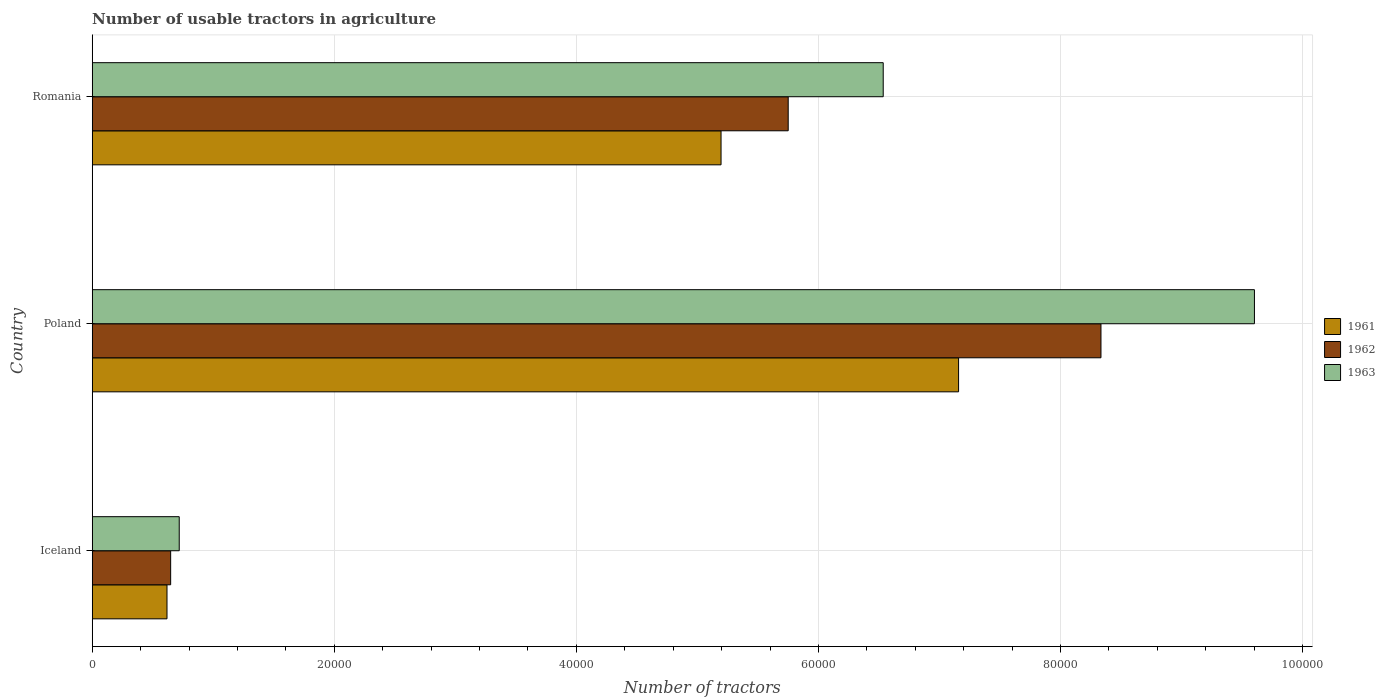How many different coloured bars are there?
Your answer should be compact. 3. Are the number of bars per tick equal to the number of legend labels?
Give a very brief answer. Yes. How many bars are there on the 2nd tick from the top?
Keep it short and to the point. 3. In how many cases, is the number of bars for a given country not equal to the number of legend labels?
Ensure brevity in your answer.  0. What is the number of usable tractors in agriculture in 1961 in Poland?
Your response must be concise. 7.16e+04. Across all countries, what is the maximum number of usable tractors in agriculture in 1963?
Provide a short and direct response. 9.60e+04. Across all countries, what is the minimum number of usable tractors in agriculture in 1962?
Offer a very short reply. 6479. In which country was the number of usable tractors in agriculture in 1963 maximum?
Provide a short and direct response. Poland. In which country was the number of usable tractors in agriculture in 1962 minimum?
Offer a terse response. Iceland. What is the total number of usable tractors in agriculture in 1962 in the graph?
Keep it short and to the point. 1.47e+05. What is the difference between the number of usable tractors in agriculture in 1963 in Iceland and that in Romania?
Make the answer very short. -5.82e+04. What is the difference between the number of usable tractors in agriculture in 1963 in Romania and the number of usable tractors in agriculture in 1962 in Iceland?
Provide a succinct answer. 5.89e+04. What is the average number of usable tractors in agriculture in 1961 per country?
Your answer should be compact. 4.32e+04. What is the difference between the number of usable tractors in agriculture in 1963 and number of usable tractors in agriculture in 1962 in Poland?
Give a very brief answer. 1.27e+04. In how many countries, is the number of usable tractors in agriculture in 1961 greater than 24000 ?
Your response must be concise. 2. What is the ratio of the number of usable tractors in agriculture in 1962 in Iceland to that in Poland?
Your answer should be compact. 0.08. Is the number of usable tractors in agriculture in 1963 in Iceland less than that in Poland?
Give a very brief answer. Yes. Is the difference between the number of usable tractors in agriculture in 1963 in Iceland and Romania greater than the difference between the number of usable tractors in agriculture in 1962 in Iceland and Romania?
Keep it short and to the point. No. What is the difference between the highest and the second highest number of usable tractors in agriculture in 1963?
Provide a short and direct response. 3.07e+04. What is the difference between the highest and the lowest number of usable tractors in agriculture in 1963?
Your answer should be compact. 8.88e+04. In how many countries, is the number of usable tractors in agriculture in 1962 greater than the average number of usable tractors in agriculture in 1962 taken over all countries?
Your response must be concise. 2. What does the 2nd bar from the top in Poland represents?
Make the answer very short. 1962. What does the 3rd bar from the bottom in Romania represents?
Offer a terse response. 1963. Is it the case that in every country, the sum of the number of usable tractors in agriculture in 1962 and number of usable tractors in agriculture in 1961 is greater than the number of usable tractors in agriculture in 1963?
Make the answer very short. Yes. How many bars are there?
Your response must be concise. 9. Are all the bars in the graph horizontal?
Keep it short and to the point. Yes. What is the difference between two consecutive major ticks on the X-axis?
Your answer should be very brief. 2.00e+04. Are the values on the major ticks of X-axis written in scientific E-notation?
Offer a very short reply. No. Does the graph contain any zero values?
Your answer should be compact. No. Where does the legend appear in the graph?
Your answer should be compact. Center right. What is the title of the graph?
Ensure brevity in your answer.  Number of usable tractors in agriculture. What is the label or title of the X-axis?
Ensure brevity in your answer.  Number of tractors. What is the Number of tractors of 1961 in Iceland?
Offer a terse response. 6177. What is the Number of tractors of 1962 in Iceland?
Provide a succinct answer. 6479. What is the Number of tractors in 1963 in Iceland?
Keep it short and to the point. 7187. What is the Number of tractors in 1961 in Poland?
Ensure brevity in your answer.  7.16e+04. What is the Number of tractors of 1962 in Poland?
Your response must be concise. 8.33e+04. What is the Number of tractors of 1963 in Poland?
Provide a succinct answer. 9.60e+04. What is the Number of tractors of 1961 in Romania?
Offer a terse response. 5.20e+04. What is the Number of tractors of 1962 in Romania?
Your response must be concise. 5.75e+04. What is the Number of tractors of 1963 in Romania?
Ensure brevity in your answer.  6.54e+04. Across all countries, what is the maximum Number of tractors in 1961?
Keep it short and to the point. 7.16e+04. Across all countries, what is the maximum Number of tractors of 1962?
Keep it short and to the point. 8.33e+04. Across all countries, what is the maximum Number of tractors of 1963?
Your answer should be very brief. 9.60e+04. Across all countries, what is the minimum Number of tractors of 1961?
Your answer should be compact. 6177. Across all countries, what is the minimum Number of tractors of 1962?
Give a very brief answer. 6479. Across all countries, what is the minimum Number of tractors of 1963?
Offer a terse response. 7187. What is the total Number of tractors in 1961 in the graph?
Keep it short and to the point. 1.30e+05. What is the total Number of tractors in 1962 in the graph?
Your answer should be very brief. 1.47e+05. What is the total Number of tractors of 1963 in the graph?
Your answer should be very brief. 1.69e+05. What is the difference between the Number of tractors in 1961 in Iceland and that in Poland?
Offer a terse response. -6.54e+04. What is the difference between the Number of tractors in 1962 in Iceland and that in Poland?
Ensure brevity in your answer.  -7.69e+04. What is the difference between the Number of tractors of 1963 in Iceland and that in Poland?
Make the answer very short. -8.88e+04. What is the difference between the Number of tractors in 1961 in Iceland and that in Romania?
Provide a succinct answer. -4.58e+04. What is the difference between the Number of tractors of 1962 in Iceland and that in Romania?
Offer a very short reply. -5.10e+04. What is the difference between the Number of tractors of 1963 in Iceland and that in Romania?
Ensure brevity in your answer.  -5.82e+04. What is the difference between the Number of tractors of 1961 in Poland and that in Romania?
Provide a succinct answer. 1.96e+04. What is the difference between the Number of tractors of 1962 in Poland and that in Romania?
Make the answer very short. 2.58e+04. What is the difference between the Number of tractors in 1963 in Poland and that in Romania?
Your response must be concise. 3.07e+04. What is the difference between the Number of tractors in 1961 in Iceland and the Number of tractors in 1962 in Poland?
Provide a short and direct response. -7.72e+04. What is the difference between the Number of tractors in 1961 in Iceland and the Number of tractors in 1963 in Poland?
Ensure brevity in your answer.  -8.98e+04. What is the difference between the Number of tractors of 1962 in Iceland and the Number of tractors of 1963 in Poland?
Give a very brief answer. -8.95e+04. What is the difference between the Number of tractors of 1961 in Iceland and the Number of tractors of 1962 in Romania?
Offer a very short reply. -5.13e+04. What is the difference between the Number of tractors of 1961 in Iceland and the Number of tractors of 1963 in Romania?
Make the answer very short. -5.92e+04. What is the difference between the Number of tractors of 1962 in Iceland and the Number of tractors of 1963 in Romania?
Your response must be concise. -5.89e+04. What is the difference between the Number of tractors of 1961 in Poland and the Number of tractors of 1962 in Romania?
Offer a terse response. 1.41e+04. What is the difference between the Number of tractors in 1961 in Poland and the Number of tractors in 1963 in Romania?
Make the answer very short. 6226. What is the difference between the Number of tractors in 1962 in Poland and the Number of tractors in 1963 in Romania?
Your answer should be very brief. 1.80e+04. What is the average Number of tractors in 1961 per country?
Ensure brevity in your answer.  4.32e+04. What is the average Number of tractors in 1962 per country?
Provide a short and direct response. 4.91e+04. What is the average Number of tractors in 1963 per country?
Your answer should be compact. 5.62e+04. What is the difference between the Number of tractors of 1961 and Number of tractors of 1962 in Iceland?
Give a very brief answer. -302. What is the difference between the Number of tractors of 1961 and Number of tractors of 1963 in Iceland?
Keep it short and to the point. -1010. What is the difference between the Number of tractors of 1962 and Number of tractors of 1963 in Iceland?
Your response must be concise. -708. What is the difference between the Number of tractors in 1961 and Number of tractors in 1962 in Poland?
Offer a terse response. -1.18e+04. What is the difference between the Number of tractors of 1961 and Number of tractors of 1963 in Poland?
Provide a short and direct response. -2.44e+04. What is the difference between the Number of tractors of 1962 and Number of tractors of 1963 in Poland?
Make the answer very short. -1.27e+04. What is the difference between the Number of tractors of 1961 and Number of tractors of 1962 in Romania?
Keep it short and to the point. -5548. What is the difference between the Number of tractors in 1961 and Number of tractors in 1963 in Romania?
Ensure brevity in your answer.  -1.34e+04. What is the difference between the Number of tractors of 1962 and Number of tractors of 1963 in Romania?
Keep it short and to the point. -7851. What is the ratio of the Number of tractors in 1961 in Iceland to that in Poland?
Your answer should be very brief. 0.09. What is the ratio of the Number of tractors of 1962 in Iceland to that in Poland?
Ensure brevity in your answer.  0.08. What is the ratio of the Number of tractors in 1963 in Iceland to that in Poland?
Your response must be concise. 0.07. What is the ratio of the Number of tractors in 1961 in Iceland to that in Romania?
Provide a succinct answer. 0.12. What is the ratio of the Number of tractors in 1962 in Iceland to that in Romania?
Your response must be concise. 0.11. What is the ratio of the Number of tractors of 1963 in Iceland to that in Romania?
Offer a very short reply. 0.11. What is the ratio of the Number of tractors in 1961 in Poland to that in Romania?
Your answer should be compact. 1.38. What is the ratio of the Number of tractors in 1962 in Poland to that in Romania?
Make the answer very short. 1.45. What is the ratio of the Number of tractors of 1963 in Poland to that in Romania?
Your answer should be very brief. 1.47. What is the difference between the highest and the second highest Number of tractors in 1961?
Your answer should be very brief. 1.96e+04. What is the difference between the highest and the second highest Number of tractors of 1962?
Give a very brief answer. 2.58e+04. What is the difference between the highest and the second highest Number of tractors of 1963?
Ensure brevity in your answer.  3.07e+04. What is the difference between the highest and the lowest Number of tractors of 1961?
Provide a short and direct response. 6.54e+04. What is the difference between the highest and the lowest Number of tractors in 1962?
Offer a very short reply. 7.69e+04. What is the difference between the highest and the lowest Number of tractors of 1963?
Offer a very short reply. 8.88e+04. 